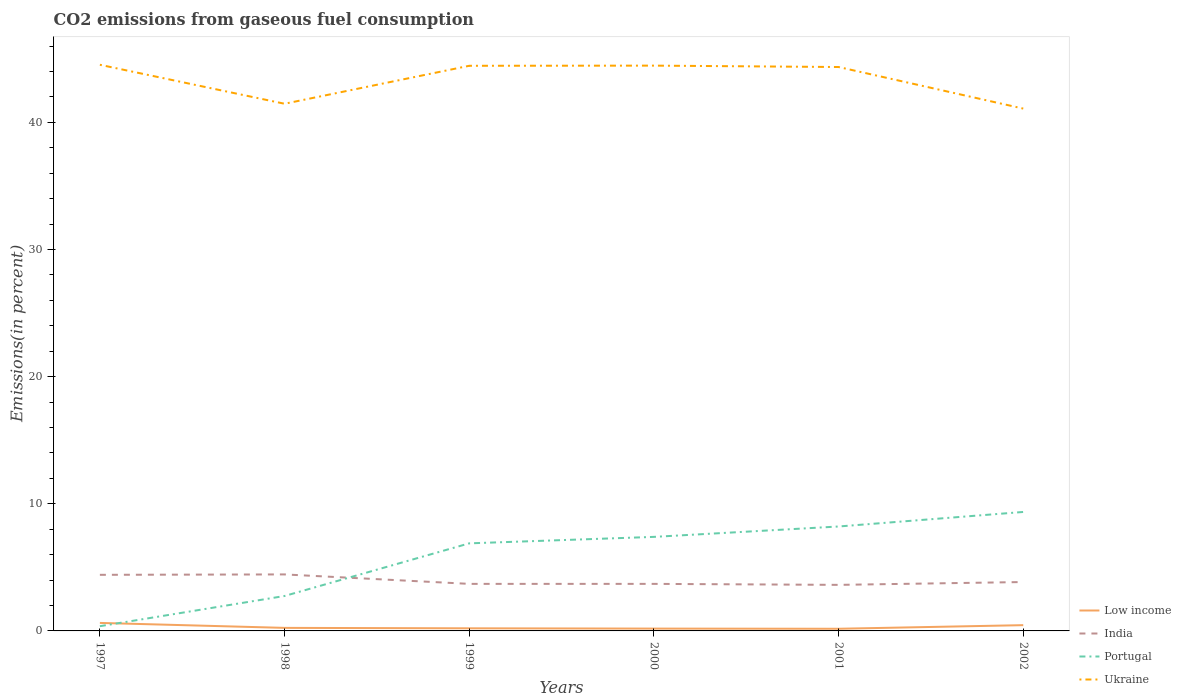Does the line corresponding to Portugal intersect with the line corresponding to Ukraine?
Provide a short and direct response. No. Across all years, what is the maximum total CO2 emitted in Ukraine?
Give a very brief answer. 41.08. In which year was the total CO2 emitted in Portugal maximum?
Provide a succinct answer. 1997. What is the total total CO2 emitted in Ukraine in the graph?
Ensure brevity in your answer.  0.38. What is the difference between the highest and the second highest total CO2 emitted in Ukraine?
Provide a succinct answer. 3.45. What is the difference between the highest and the lowest total CO2 emitted in Portugal?
Give a very brief answer. 4. Is the total CO2 emitted in India strictly greater than the total CO2 emitted in Portugal over the years?
Provide a succinct answer. No. Are the values on the major ticks of Y-axis written in scientific E-notation?
Your answer should be very brief. No. Does the graph contain any zero values?
Your answer should be very brief. No. What is the title of the graph?
Your answer should be very brief. CO2 emissions from gaseous fuel consumption. Does "Malta" appear as one of the legend labels in the graph?
Your response must be concise. No. What is the label or title of the Y-axis?
Ensure brevity in your answer.  Emissions(in percent). What is the Emissions(in percent) of Low income in 1997?
Provide a short and direct response. 0.63. What is the Emissions(in percent) in India in 1997?
Offer a terse response. 4.41. What is the Emissions(in percent) of Portugal in 1997?
Keep it short and to the point. 0.37. What is the Emissions(in percent) of Ukraine in 1997?
Offer a terse response. 44.53. What is the Emissions(in percent) of Low income in 1998?
Ensure brevity in your answer.  0.24. What is the Emissions(in percent) of India in 1998?
Provide a succinct answer. 4.44. What is the Emissions(in percent) in Portugal in 1998?
Give a very brief answer. 2.75. What is the Emissions(in percent) of Ukraine in 1998?
Offer a very short reply. 41.46. What is the Emissions(in percent) of Low income in 1999?
Keep it short and to the point. 0.21. What is the Emissions(in percent) of India in 1999?
Ensure brevity in your answer.  3.7. What is the Emissions(in percent) in Portugal in 1999?
Give a very brief answer. 6.89. What is the Emissions(in percent) of Ukraine in 1999?
Keep it short and to the point. 44.45. What is the Emissions(in percent) in Low income in 2000?
Your answer should be very brief. 0.18. What is the Emissions(in percent) in India in 2000?
Your answer should be very brief. 3.7. What is the Emissions(in percent) of Portugal in 2000?
Offer a terse response. 7.4. What is the Emissions(in percent) of Ukraine in 2000?
Give a very brief answer. 44.46. What is the Emissions(in percent) in Low income in 2001?
Your answer should be very brief. 0.17. What is the Emissions(in percent) in India in 2001?
Give a very brief answer. 3.62. What is the Emissions(in percent) of Portugal in 2001?
Your response must be concise. 8.21. What is the Emissions(in percent) in Ukraine in 2001?
Give a very brief answer. 44.35. What is the Emissions(in percent) in Low income in 2002?
Your answer should be compact. 0.45. What is the Emissions(in percent) in India in 2002?
Make the answer very short. 3.85. What is the Emissions(in percent) in Portugal in 2002?
Your response must be concise. 9.36. What is the Emissions(in percent) in Ukraine in 2002?
Offer a terse response. 41.08. Across all years, what is the maximum Emissions(in percent) of Low income?
Offer a very short reply. 0.63. Across all years, what is the maximum Emissions(in percent) in India?
Provide a succinct answer. 4.44. Across all years, what is the maximum Emissions(in percent) of Portugal?
Offer a terse response. 9.36. Across all years, what is the maximum Emissions(in percent) of Ukraine?
Offer a very short reply. 44.53. Across all years, what is the minimum Emissions(in percent) of Low income?
Give a very brief answer. 0.17. Across all years, what is the minimum Emissions(in percent) in India?
Make the answer very short. 3.62. Across all years, what is the minimum Emissions(in percent) in Portugal?
Your answer should be very brief. 0.37. Across all years, what is the minimum Emissions(in percent) of Ukraine?
Ensure brevity in your answer.  41.08. What is the total Emissions(in percent) of Low income in the graph?
Offer a terse response. 1.88. What is the total Emissions(in percent) of India in the graph?
Your answer should be very brief. 23.72. What is the total Emissions(in percent) of Portugal in the graph?
Offer a terse response. 34.97. What is the total Emissions(in percent) in Ukraine in the graph?
Your answer should be very brief. 260.33. What is the difference between the Emissions(in percent) of Low income in 1997 and that in 1998?
Your answer should be compact. 0.39. What is the difference between the Emissions(in percent) in India in 1997 and that in 1998?
Keep it short and to the point. -0.03. What is the difference between the Emissions(in percent) in Portugal in 1997 and that in 1998?
Make the answer very short. -2.38. What is the difference between the Emissions(in percent) in Ukraine in 1997 and that in 1998?
Your answer should be very brief. 3.07. What is the difference between the Emissions(in percent) in Low income in 1997 and that in 1999?
Provide a succinct answer. 0.42. What is the difference between the Emissions(in percent) in India in 1997 and that in 1999?
Provide a succinct answer. 0.71. What is the difference between the Emissions(in percent) of Portugal in 1997 and that in 1999?
Your answer should be compact. -6.52. What is the difference between the Emissions(in percent) of Ukraine in 1997 and that in 1999?
Offer a very short reply. 0.08. What is the difference between the Emissions(in percent) of Low income in 1997 and that in 2000?
Your answer should be compact. 0.45. What is the difference between the Emissions(in percent) of India in 1997 and that in 2000?
Offer a very short reply. 0.71. What is the difference between the Emissions(in percent) of Portugal in 1997 and that in 2000?
Ensure brevity in your answer.  -7.02. What is the difference between the Emissions(in percent) of Ukraine in 1997 and that in 2000?
Ensure brevity in your answer.  0.07. What is the difference between the Emissions(in percent) of Low income in 1997 and that in 2001?
Your answer should be very brief. 0.46. What is the difference between the Emissions(in percent) in India in 1997 and that in 2001?
Keep it short and to the point. 0.79. What is the difference between the Emissions(in percent) of Portugal in 1997 and that in 2001?
Your response must be concise. -7.84. What is the difference between the Emissions(in percent) of Ukraine in 1997 and that in 2001?
Your answer should be compact. 0.18. What is the difference between the Emissions(in percent) in Low income in 1997 and that in 2002?
Your answer should be very brief. 0.18. What is the difference between the Emissions(in percent) in India in 1997 and that in 2002?
Keep it short and to the point. 0.57. What is the difference between the Emissions(in percent) in Portugal in 1997 and that in 2002?
Your answer should be compact. -8.98. What is the difference between the Emissions(in percent) of Ukraine in 1997 and that in 2002?
Offer a very short reply. 3.45. What is the difference between the Emissions(in percent) of Low income in 1998 and that in 1999?
Ensure brevity in your answer.  0.03. What is the difference between the Emissions(in percent) of India in 1998 and that in 1999?
Provide a short and direct response. 0.74. What is the difference between the Emissions(in percent) of Portugal in 1998 and that in 1999?
Ensure brevity in your answer.  -4.14. What is the difference between the Emissions(in percent) of Ukraine in 1998 and that in 1999?
Offer a very short reply. -2.99. What is the difference between the Emissions(in percent) of Low income in 1998 and that in 2000?
Keep it short and to the point. 0.06. What is the difference between the Emissions(in percent) of India in 1998 and that in 2000?
Your answer should be compact. 0.74. What is the difference between the Emissions(in percent) of Portugal in 1998 and that in 2000?
Keep it short and to the point. -4.65. What is the difference between the Emissions(in percent) in Ukraine in 1998 and that in 2000?
Your response must be concise. -3. What is the difference between the Emissions(in percent) of Low income in 1998 and that in 2001?
Provide a succinct answer. 0.07. What is the difference between the Emissions(in percent) of India in 1998 and that in 2001?
Your response must be concise. 0.82. What is the difference between the Emissions(in percent) in Portugal in 1998 and that in 2001?
Your answer should be very brief. -5.47. What is the difference between the Emissions(in percent) of Ukraine in 1998 and that in 2001?
Make the answer very short. -2.89. What is the difference between the Emissions(in percent) of Low income in 1998 and that in 2002?
Provide a succinct answer. -0.21. What is the difference between the Emissions(in percent) of India in 1998 and that in 2002?
Give a very brief answer. 0.6. What is the difference between the Emissions(in percent) of Portugal in 1998 and that in 2002?
Give a very brief answer. -6.61. What is the difference between the Emissions(in percent) of Ukraine in 1998 and that in 2002?
Offer a terse response. 0.38. What is the difference between the Emissions(in percent) of Low income in 1999 and that in 2000?
Your response must be concise. 0.02. What is the difference between the Emissions(in percent) in Portugal in 1999 and that in 2000?
Make the answer very short. -0.51. What is the difference between the Emissions(in percent) of Ukraine in 1999 and that in 2000?
Your response must be concise. -0.01. What is the difference between the Emissions(in percent) of Low income in 1999 and that in 2001?
Ensure brevity in your answer.  0.04. What is the difference between the Emissions(in percent) of India in 1999 and that in 2001?
Keep it short and to the point. 0.08. What is the difference between the Emissions(in percent) in Portugal in 1999 and that in 2001?
Keep it short and to the point. -1.33. What is the difference between the Emissions(in percent) in Ukraine in 1999 and that in 2001?
Provide a short and direct response. 0.1. What is the difference between the Emissions(in percent) in Low income in 1999 and that in 2002?
Keep it short and to the point. -0.25. What is the difference between the Emissions(in percent) in India in 1999 and that in 2002?
Keep it short and to the point. -0.14. What is the difference between the Emissions(in percent) of Portugal in 1999 and that in 2002?
Give a very brief answer. -2.47. What is the difference between the Emissions(in percent) in Ukraine in 1999 and that in 2002?
Make the answer very short. 3.37. What is the difference between the Emissions(in percent) of Low income in 2000 and that in 2001?
Ensure brevity in your answer.  0.01. What is the difference between the Emissions(in percent) of India in 2000 and that in 2001?
Your response must be concise. 0.08. What is the difference between the Emissions(in percent) of Portugal in 2000 and that in 2001?
Offer a terse response. -0.82. What is the difference between the Emissions(in percent) in Ukraine in 2000 and that in 2001?
Offer a terse response. 0.11. What is the difference between the Emissions(in percent) of Low income in 2000 and that in 2002?
Provide a short and direct response. -0.27. What is the difference between the Emissions(in percent) of India in 2000 and that in 2002?
Your answer should be compact. -0.14. What is the difference between the Emissions(in percent) in Portugal in 2000 and that in 2002?
Offer a very short reply. -1.96. What is the difference between the Emissions(in percent) in Ukraine in 2000 and that in 2002?
Offer a very short reply. 3.38. What is the difference between the Emissions(in percent) in Low income in 2001 and that in 2002?
Provide a succinct answer. -0.28. What is the difference between the Emissions(in percent) of India in 2001 and that in 2002?
Your response must be concise. -0.22. What is the difference between the Emissions(in percent) in Portugal in 2001 and that in 2002?
Give a very brief answer. -1.14. What is the difference between the Emissions(in percent) in Ukraine in 2001 and that in 2002?
Make the answer very short. 3.27. What is the difference between the Emissions(in percent) in Low income in 1997 and the Emissions(in percent) in India in 1998?
Provide a succinct answer. -3.81. What is the difference between the Emissions(in percent) of Low income in 1997 and the Emissions(in percent) of Portugal in 1998?
Your response must be concise. -2.12. What is the difference between the Emissions(in percent) in Low income in 1997 and the Emissions(in percent) in Ukraine in 1998?
Make the answer very short. -40.83. What is the difference between the Emissions(in percent) in India in 1997 and the Emissions(in percent) in Portugal in 1998?
Provide a short and direct response. 1.66. What is the difference between the Emissions(in percent) in India in 1997 and the Emissions(in percent) in Ukraine in 1998?
Your response must be concise. -37.05. What is the difference between the Emissions(in percent) in Portugal in 1997 and the Emissions(in percent) in Ukraine in 1998?
Offer a terse response. -41.09. What is the difference between the Emissions(in percent) in Low income in 1997 and the Emissions(in percent) in India in 1999?
Keep it short and to the point. -3.07. What is the difference between the Emissions(in percent) in Low income in 1997 and the Emissions(in percent) in Portugal in 1999?
Your response must be concise. -6.26. What is the difference between the Emissions(in percent) in Low income in 1997 and the Emissions(in percent) in Ukraine in 1999?
Give a very brief answer. -43.82. What is the difference between the Emissions(in percent) of India in 1997 and the Emissions(in percent) of Portugal in 1999?
Your answer should be very brief. -2.48. What is the difference between the Emissions(in percent) of India in 1997 and the Emissions(in percent) of Ukraine in 1999?
Provide a short and direct response. -40.04. What is the difference between the Emissions(in percent) of Portugal in 1997 and the Emissions(in percent) of Ukraine in 1999?
Ensure brevity in your answer.  -44.08. What is the difference between the Emissions(in percent) of Low income in 1997 and the Emissions(in percent) of India in 2000?
Offer a terse response. -3.07. What is the difference between the Emissions(in percent) of Low income in 1997 and the Emissions(in percent) of Portugal in 2000?
Provide a short and direct response. -6.77. What is the difference between the Emissions(in percent) in Low income in 1997 and the Emissions(in percent) in Ukraine in 2000?
Your answer should be compact. -43.83. What is the difference between the Emissions(in percent) in India in 1997 and the Emissions(in percent) in Portugal in 2000?
Give a very brief answer. -2.98. What is the difference between the Emissions(in percent) in India in 1997 and the Emissions(in percent) in Ukraine in 2000?
Give a very brief answer. -40.05. What is the difference between the Emissions(in percent) in Portugal in 1997 and the Emissions(in percent) in Ukraine in 2000?
Your answer should be very brief. -44.09. What is the difference between the Emissions(in percent) of Low income in 1997 and the Emissions(in percent) of India in 2001?
Provide a succinct answer. -2.99. What is the difference between the Emissions(in percent) in Low income in 1997 and the Emissions(in percent) in Portugal in 2001?
Keep it short and to the point. -7.58. What is the difference between the Emissions(in percent) in Low income in 1997 and the Emissions(in percent) in Ukraine in 2001?
Ensure brevity in your answer.  -43.72. What is the difference between the Emissions(in percent) of India in 1997 and the Emissions(in percent) of Portugal in 2001?
Give a very brief answer. -3.8. What is the difference between the Emissions(in percent) of India in 1997 and the Emissions(in percent) of Ukraine in 2001?
Offer a very short reply. -39.94. What is the difference between the Emissions(in percent) in Portugal in 1997 and the Emissions(in percent) in Ukraine in 2001?
Your answer should be very brief. -43.98. What is the difference between the Emissions(in percent) in Low income in 1997 and the Emissions(in percent) in India in 2002?
Your answer should be very brief. -3.22. What is the difference between the Emissions(in percent) in Low income in 1997 and the Emissions(in percent) in Portugal in 2002?
Make the answer very short. -8.73. What is the difference between the Emissions(in percent) of Low income in 1997 and the Emissions(in percent) of Ukraine in 2002?
Offer a terse response. -40.45. What is the difference between the Emissions(in percent) in India in 1997 and the Emissions(in percent) in Portugal in 2002?
Your answer should be compact. -4.94. What is the difference between the Emissions(in percent) in India in 1997 and the Emissions(in percent) in Ukraine in 2002?
Keep it short and to the point. -36.67. What is the difference between the Emissions(in percent) in Portugal in 1997 and the Emissions(in percent) in Ukraine in 2002?
Your response must be concise. -40.71. What is the difference between the Emissions(in percent) in Low income in 1998 and the Emissions(in percent) in India in 1999?
Your answer should be compact. -3.46. What is the difference between the Emissions(in percent) in Low income in 1998 and the Emissions(in percent) in Portugal in 1999?
Ensure brevity in your answer.  -6.65. What is the difference between the Emissions(in percent) of Low income in 1998 and the Emissions(in percent) of Ukraine in 1999?
Offer a terse response. -44.21. What is the difference between the Emissions(in percent) in India in 1998 and the Emissions(in percent) in Portugal in 1999?
Your response must be concise. -2.44. What is the difference between the Emissions(in percent) of India in 1998 and the Emissions(in percent) of Ukraine in 1999?
Offer a very short reply. -40. What is the difference between the Emissions(in percent) of Portugal in 1998 and the Emissions(in percent) of Ukraine in 1999?
Ensure brevity in your answer.  -41.7. What is the difference between the Emissions(in percent) in Low income in 1998 and the Emissions(in percent) in India in 2000?
Keep it short and to the point. -3.46. What is the difference between the Emissions(in percent) of Low income in 1998 and the Emissions(in percent) of Portugal in 2000?
Keep it short and to the point. -7.16. What is the difference between the Emissions(in percent) in Low income in 1998 and the Emissions(in percent) in Ukraine in 2000?
Provide a succinct answer. -44.22. What is the difference between the Emissions(in percent) in India in 1998 and the Emissions(in percent) in Portugal in 2000?
Your answer should be compact. -2.95. What is the difference between the Emissions(in percent) of India in 1998 and the Emissions(in percent) of Ukraine in 2000?
Your answer should be very brief. -40.02. What is the difference between the Emissions(in percent) of Portugal in 1998 and the Emissions(in percent) of Ukraine in 2000?
Your response must be concise. -41.71. What is the difference between the Emissions(in percent) in Low income in 1998 and the Emissions(in percent) in India in 2001?
Ensure brevity in your answer.  -3.38. What is the difference between the Emissions(in percent) of Low income in 1998 and the Emissions(in percent) of Portugal in 2001?
Your answer should be compact. -7.97. What is the difference between the Emissions(in percent) of Low income in 1998 and the Emissions(in percent) of Ukraine in 2001?
Ensure brevity in your answer.  -44.11. What is the difference between the Emissions(in percent) of India in 1998 and the Emissions(in percent) of Portugal in 2001?
Your answer should be compact. -3.77. What is the difference between the Emissions(in percent) of India in 1998 and the Emissions(in percent) of Ukraine in 2001?
Offer a very short reply. -39.91. What is the difference between the Emissions(in percent) in Portugal in 1998 and the Emissions(in percent) in Ukraine in 2001?
Your answer should be very brief. -41.6. What is the difference between the Emissions(in percent) in Low income in 1998 and the Emissions(in percent) in India in 2002?
Your answer should be very brief. -3.61. What is the difference between the Emissions(in percent) of Low income in 1998 and the Emissions(in percent) of Portugal in 2002?
Offer a very short reply. -9.12. What is the difference between the Emissions(in percent) in Low income in 1998 and the Emissions(in percent) in Ukraine in 2002?
Your response must be concise. -40.84. What is the difference between the Emissions(in percent) of India in 1998 and the Emissions(in percent) of Portugal in 2002?
Offer a terse response. -4.91. What is the difference between the Emissions(in percent) in India in 1998 and the Emissions(in percent) in Ukraine in 2002?
Ensure brevity in your answer.  -36.64. What is the difference between the Emissions(in percent) of Portugal in 1998 and the Emissions(in percent) of Ukraine in 2002?
Your answer should be very brief. -38.33. What is the difference between the Emissions(in percent) in Low income in 1999 and the Emissions(in percent) in India in 2000?
Provide a succinct answer. -3.5. What is the difference between the Emissions(in percent) in Low income in 1999 and the Emissions(in percent) in Portugal in 2000?
Ensure brevity in your answer.  -7.19. What is the difference between the Emissions(in percent) in Low income in 1999 and the Emissions(in percent) in Ukraine in 2000?
Make the answer very short. -44.26. What is the difference between the Emissions(in percent) of India in 1999 and the Emissions(in percent) of Portugal in 2000?
Provide a succinct answer. -3.7. What is the difference between the Emissions(in percent) of India in 1999 and the Emissions(in percent) of Ukraine in 2000?
Offer a very short reply. -40.76. What is the difference between the Emissions(in percent) of Portugal in 1999 and the Emissions(in percent) of Ukraine in 2000?
Make the answer very short. -37.57. What is the difference between the Emissions(in percent) of Low income in 1999 and the Emissions(in percent) of India in 2001?
Ensure brevity in your answer.  -3.42. What is the difference between the Emissions(in percent) in Low income in 1999 and the Emissions(in percent) in Portugal in 2001?
Provide a short and direct response. -8.01. What is the difference between the Emissions(in percent) of Low income in 1999 and the Emissions(in percent) of Ukraine in 2001?
Provide a succinct answer. -44.15. What is the difference between the Emissions(in percent) in India in 1999 and the Emissions(in percent) in Portugal in 2001?
Provide a short and direct response. -4.51. What is the difference between the Emissions(in percent) of India in 1999 and the Emissions(in percent) of Ukraine in 2001?
Offer a very short reply. -40.65. What is the difference between the Emissions(in percent) of Portugal in 1999 and the Emissions(in percent) of Ukraine in 2001?
Offer a terse response. -37.46. What is the difference between the Emissions(in percent) in Low income in 1999 and the Emissions(in percent) in India in 2002?
Ensure brevity in your answer.  -3.64. What is the difference between the Emissions(in percent) of Low income in 1999 and the Emissions(in percent) of Portugal in 2002?
Offer a terse response. -9.15. What is the difference between the Emissions(in percent) in Low income in 1999 and the Emissions(in percent) in Ukraine in 2002?
Your answer should be compact. -40.88. What is the difference between the Emissions(in percent) of India in 1999 and the Emissions(in percent) of Portugal in 2002?
Provide a succinct answer. -5.66. What is the difference between the Emissions(in percent) in India in 1999 and the Emissions(in percent) in Ukraine in 2002?
Provide a short and direct response. -37.38. What is the difference between the Emissions(in percent) in Portugal in 1999 and the Emissions(in percent) in Ukraine in 2002?
Provide a succinct answer. -34.19. What is the difference between the Emissions(in percent) in Low income in 2000 and the Emissions(in percent) in India in 2001?
Your response must be concise. -3.44. What is the difference between the Emissions(in percent) of Low income in 2000 and the Emissions(in percent) of Portugal in 2001?
Ensure brevity in your answer.  -8.03. What is the difference between the Emissions(in percent) in Low income in 2000 and the Emissions(in percent) in Ukraine in 2001?
Your response must be concise. -44.17. What is the difference between the Emissions(in percent) of India in 2000 and the Emissions(in percent) of Portugal in 2001?
Give a very brief answer. -4.51. What is the difference between the Emissions(in percent) in India in 2000 and the Emissions(in percent) in Ukraine in 2001?
Your answer should be very brief. -40.65. What is the difference between the Emissions(in percent) of Portugal in 2000 and the Emissions(in percent) of Ukraine in 2001?
Give a very brief answer. -36.95. What is the difference between the Emissions(in percent) of Low income in 2000 and the Emissions(in percent) of India in 2002?
Give a very brief answer. -3.66. What is the difference between the Emissions(in percent) of Low income in 2000 and the Emissions(in percent) of Portugal in 2002?
Make the answer very short. -9.17. What is the difference between the Emissions(in percent) in Low income in 2000 and the Emissions(in percent) in Ukraine in 2002?
Ensure brevity in your answer.  -40.9. What is the difference between the Emissions(in percent) of India in 2000 and the Emissions(in percent) of Portugal in 2002?
Your answer should be compact. -5.66. What is the difference between the Emissions(in percent) in India in 2000 and the Emissions(in percent) in Ukraine in 2002?
Your response must be concise. -37.38. What is the difference between the Emissions(in percent) in Portugal in 2000 and the Emissions(in percent) in Ukraine in 2002?
Give a very brief answer. -33.68. What is the difference between the Emissions(in percent) of Low income in 2001 and the Emissions(in percent) of India in 2002?
Make the answer very short. -3.68. What is the difference between the Emissions(in percent) of Low income in 2001 and the Emissions(in percent) of Portugal in 2002?
Give a very brief answer. -9.19. What is the difference between the Emissions(in percent) of Low income in 2001 and the Emissions(in percent) of Ukraine in 2002?
Offer a terse response. -40.91. What is the difference between the Emissions(in percent) in India in 2001 and the Emissions(in percent) in Portugal in 2002?
Your answer should be very brief. -5.73. What is the difference between the Emissions(in percent) in India in 2001 and the Emissions(in percent) in Ukraine in 2002?
Provide a short and direct response. -37.46. What is the difference between the Emissions(in percent) in Portugal in 2001 and the Emissions(in percent) in Ukraine in 2002?
Offer a very short reply. -32.87. What is the average Emissions(in percent) of Low income per year?
Your answer should be very brief. 0.31. What is the average Emissions(in percent) of India per year?
Your answer should be very brief. 3.95. What is the average Emissions(in percent) of Portugal per year?
Keep it short and to the point. 5.83. What is the average Emissions(in percent) in Ukraine per year?
Your answer should be compact. 43.39. In the year 1997, what is the difference between the Emissions(in percent) of Low income and Emissions(in percent) of India?
Your answer should be compact. -3.78. In the year 1997, what is the difference between the Emissions(in percent) of Low income and Emissions(in percent) of Portugal?
Keep it short and to the point. 0.26. In the year 1997, what is the difference between the Emissions(in percent) of Low income and Emissions(in percent) of Ukraine?
Ensure brevity in your answer.  -43.9. In the year 1997, what is the difference between the Emissions(in percent) of India and Emissions(in percent) of Portugal?
Provide a succinct answer. 4.04. In the year 1997, what is the difference between the Emissions(in percent) in India and Emissions(in percent) in Ukraine?
Your answer should be compact. -40.11. In the year 1997, what is the difference between the Emissions(in percent) in Portugal and Emissions(in percent) in Ukraine?
Provide a short and direct response. -44.15. In the year 1998, what is the difference between the Emissions(in percent) in Low income and Emissions(in percent) in India?
Your response must be concise. -4.2. In the year 1998, what is the difference between the Emissions(in percent) in Low income and Emissions(in percent) in Portugal?
Ensure brevity in your answer.  -2.51. In the year 1998, what is the difference between the Emissions(in percent) in Low income and Emissions(in percent) in Ukraine?
Keep it short and to the point. -41.22. In the year 1998, what is the difference between the Emissions(in percent) in India and Emissions(in percent) in Portugal?
Keep it short and to the point. 1.7. In the year 1998, what is the difference between the Emissions(in percent) of India and Emissions(in percent) of Ukraine?
Keep it short and to the point. -37.02. In the year 1998, what is the difference between the Emissions(in percent) in Portugal and Emissions(in percent) in Ukraine?
Offer a terse response. -38.71. In the year 1999, what is the difference between the Emissions(in percent) in Low income and Emissions(in percent) in India?
Offer a very short reply. -3.5. In the year 1999, what is the difference between the Emissions(in percent) of Low income and Emissions(in percent) of Portugal?
Your answer should be very brief. -6.68. In the year 1999, what is the difference between the Emissions(in percent) of Low income and Emissions(in percent) of Ukraine?
Keep it short and to the point. -44.24. In the year 1999, what is the difference between the Emissions(in percent) in India and Emissions(in percent) in Portugal?
Give a very brief answer. -3.19. In the year 1999, what is the difference between the Emissions(in percent) in India and Emissions(in percent) in Ukraine?
Offer a very short reply. -40.75. In the year 1999, what is the difference between the Emissions(in percent) of Portugal and Emissions(in percent) of Ukraine?
Provide a short and direct response. -37.56. In the year 2000, what is the difference between the Emissions(in percent) in Low income and Emissions(in percent) in India?
Make the answer very short. -3.52. In the year 2000, what is the difference between the Emissions(in percent) in Low income and Emissions(in percent) in Portugal?
Your response must be concise. -7.21. In the year 2000, what is the difference between the Emissions(in percent) in Low income and Emissions(in percent) in Ukraine?
Provide a succinct answer. -44.28. In the year 2000, what is the difference between the Emissions(in percent) of India and Emissions(in percent) of Portugal?
Provide a succinct answer. -3.7. In the year 2000, what is the difference between the Emissions(in percent) in India and Emissions(in percent) in Ukraine?
Your response must be concise. -40.76. In the year 2000, what is the difference between the Emissions(in percent) of Portugal and Emissions(in percent) of Ukraine?
Ensure brevity in your answer.  -37.06. In the year 2001, what is the difference between the Emissions(in percent) of Low income and Emissions(in percent) of India?
Your response must be concise. -3.45. In the year 2001, what is the difference between the Emissions(in percent) in Low income and Emissions(in percent) in Portugal?
Offer a very short reply. -8.04. In the year 2001, what is the difference between the Emissions(in percent) of Low income and Emissions(in percent) of Ukraine?
Your response must be concise. -44.18. In the year 2001, what is the difference between the Emissions(in percent) in India and Emissions(in percent) in Portugal?
Make the answer very short. -4.59. In the year 2001, what is the difference between the Emissions(in percent) of India and Emissions(in percent) of Ukraine?
Give a very brief answer. -40.73. In the year 2001, what is the difference between the Emissions(in percent) in Portugal and Emissions(in percent) in Ukraine?
Your response must be concise. -36.14. In the year 2002, what is the difference between the Emissions(in percent) in Low income and Emissions(in percent) in India?
Your answer should be very brief. -3.39. In the year 2002, what is the difference between the Emissions(in percent) in Low income and Emissions(in percent) in Portugal?
Give a very brief answer. -8.9. In the year 2002, what is the difference between the Emissions(in percent) in Low income and Emissions(in percent) in Ukraine?
Your response must be concise. -40.63. In the year 2002, what is the difference between the Emissions(in percent) in India and Emissions(in percent) in Portugal?
Keep it short and to the point. -5.51. In the year 2002, what is the difference between the Emissions(in percent) in India and Emissions(in percent) in Ukraine?
Your response must be concise. -37.24. In the year 2002, what is the difference between the Emissions(in percent) of Portugal and Emissions(in percent) of Ukraine?
Offer a terse response. -31.72. What is the ratio of the Emissions(in percent) in Low income in 1997 to that in 1998?
Give a very brief answer. 2.63. What is the ratio of the Emissions(in percent) of Portugal in 1997 to that in 1998?
Keep it short and to the point. 0.14. What is the ratio of the Emissions(in percent) of Ukraine in 1997 to that in 1998?
Your response must be concise. 1.07. What is the ratio of the Emissions(in percent) in Low income in 1997 to that in 1999?
Provide a succinct answer. 3.07. What is the ratio of the Emissions(in percent) of India in 1997 to that in 1999?
Keep it short and to the point. 1.19. What is the ratio of the Emissions(in percent) in Portugal in 1997 to that in 1999?
Offer a terse response. 0.05. What is the ratio of the Emissions(in percent) of Ukraine in 1997 to that in 1999?
Your answer should be very brief. 1. What is the ratio of the Emissions(in percent) in Low income in 1997 to that in 2000?
Provide a succinct answer. 3.44. What is the ratio of the Emissions(in percent) in India in 1997 to that in 2000?
Your response must be concise. 1.19. What is the ratio of the Emissions(in percent) of Portugal in 1997 to that in 2000?
Your response must be concise. 0.05. What is the ratio of the Emissions(in percent) in Ukraine in 1997 to that in 2000?
Your answer should be compact. 1. What is the ratio of the Emissions(in percent) of Low income in 1997 to that in 2001?
Give a very brief answer. 3.72. What is the ratio of the Emissions(in percent) in India in 1997 to that in 2001?
Provide a short and direct response. 1.22. What is the ratio of the Emissions(in percent) in Portugal in 1997 to that in 2001?
Keep it short and to the point. 0.05. What is the ratio of the Emissions(in percent) of Ukraine in 1997 to that in 2001?
Your answer should be very brief. 1. What is the ratio of the Emissions(in percent) in Low income in 1997 to that in 2002?
Your answer should be compact. 1.39. What is the ratio of the Emissions(in percent) in India in 1997 to that in 2002?
Provide a short and direct response. 1.15. What is the ratio of the Emissions(in percent) of Portugal in 1997 to that in 2002?
Make the answer very short. 0.04. What is the ratio of the Emissions(in percent) in Ukraine in 1997 to that in 2002?
Ensure brevity in your answer.  1.08. What is the ratio of the Emissions(in percent) of Low income in 1998 to that in 1999?
Offer a terse response. 1.17. What is the ratio of the Emissions(in percent) in India in 1998 to that in 1999?
Provide a succinct answer. 1.2. What is the ratio of the Emissions(in percent) of Portugal in 1998 to that in 1999?
Give a very brief answer. 0.4. What is the ratio of the Emissions(in percent) in Ukraine in 1998 to that in 1999?
Give a very brief answer. 0.93. What is the ratio of the Emissions(in percent) of Low income in 1998 to that in 2000?
Your response must be concise. 1.31. What is the ratio of the Emissions(in percent) of India in 1998 to that in 2000?
Provide a short and direct response. 1.2. What is the ratio of the Emissions(in percent) in Portugal in 1998 to that in 2000?
Your response must be concise. 0.37. What is the ratio of the Emissions(in percent) of Ukraine in 1998 to that in 2000?
Provide a succinct answer. 0.93. What is the ratio of the Emissions(in percent) in Low income in 1998 to that in 2001?
Offer a terse response. 1.42. What is the ratio of the Emissions(in percent) of India in 1998 to that in 2001?
Ensure brevity in your answer.  1.23. What is the ratio of the Emissions(in percent) in Portugal in 1998 to that in 2001?
Keep it short and to the point. 0.33. What is the ratio of the Emissions(in percent) in Ukraine in 1998 to that in 2001?
Provide a succinct answer. 0.93. What is the ratio of the Emissions(in percent) in Low income in 1998 to that in 2002?
Your response must be concise. 0.53. What is the ratio of the Emissions(in percent) in India in 1998 to that in 2002?
Your response must be concise. 1.16. What is the ratio of the Emissions(in percent) of Portugal in 1998 to that in 2002?
Ensure brevity in your answer.  0.29. What is the ratio of the Emissions(in percent) in Ukraine in 1998 to that in 2002?
Keep it short and to the point. 1.01. What is the ratio of the Emissions(in percent) in Low income in 1999 to that in 2000?
Ensure brevity in your answer.  1.12. What is the ratio of the Emissions(in percent) of Portugal in 1999 to that in 2000?
Offer a terse response. 0.93. What is the ratio of the Emissions(in percent) in Ukraine in 1999 to that in 2000?
Offer a terse response. 1. What is the ratio of the Emissions(in percent) of Low income in 1999 to that in 2001?
Offer a terse response. 1.21. What is the ratio of the Emissions(in percent) of India in 1999 to that in 2001?
Your answer should be very brief. 1.02. What is the ratio of the Emissions(in percent) in Portugal in 1999 to that in 2001?
Your answer should be very brief. 0.84. What is the ratio of the Emissions(in percent) in Ukraine in 1999 to that in 2001?
Provide a succinct answer. 1. What is the ratio of the Emissions(in percent) in Low income in 1999 to that in 2002?
Offer a very short reply. 0.45. What is the ratio of the Emissions(in percent) in India in 1999 to that in 2002?
Your answer should be compact. 0.96. What is the ratio of the Emissions(in percent) in Portugal in 1999 to that in 2002?
Make the answer very short. 0.74. What is the ratio of the Emissions(in percent) in Ukraine in 1999 to that in 2002?
Provide a succinct answer. 1.08. What is the ratio of the Emissions(in percent) of Low income in 2000 to that in 2001?
Make the answer very short. 1.08. What is the ratio of the Emissions(in percent) of India in 2000 to that in 2001?
Your answer should be compact. 1.02. What is the ratio of the Emissions(in percent) of Portugal in 2000 to that in 2001?
Your answer should be very brief. 0.9. What is the ratio of the Emissions(in percent) in Ukraine in 2000 to that in 2001?
Provide a succinct answer. 1. What is the ratio of the Emissions(in percent) of Low income in 2000 to that in 2002?
Offer a terse response. 0.4. What is the ratio of the Emissions(in percent) in India in 2000 to that in 2002?
Your answer should be compact. 0.96. What is the ratio of the Emissions(in percent) of Portugal in 2000 to that in 2002?
Offer a terse response. 0.79. What is the ratio of the Emissions(in percent) of Ukraine in 2000 to that in 2002?
Your answer should be compact. 1.08. What is the ratio of the Emissions(in percent) of Low income in 2001 to that in 2002?
Give a very brief answer. 0.37. What is the ratio of the Emissions(in percent) of India in 2001 to that in 2002?
Provide a succinct answer. 0.94. What is the ratio of the Emissions(in percent) in Portugal in 2001 to that in 2002?
Provide a succinct answer. 0.88. What is the ratio of the Emissions(in percent) in Ukraine in 2001 to that in 2002?
Give a very brief answer. 1.08. What is the difference between the highest and the second highest Emissions(in percent) in Low income?
Keep it short and to the point. 0.18. What is the difference between the highest and the second highest Emissions(in percent) in India?
Your answer should be compact. 0.03. What is the difference between the highest and the second highest Emissions(in percent) of Portugal?
Provide a succinct answer. 1.14. What is the difference between the highest and the second highest Emissions(in percent) of Ukraine?
Give a very brief answer. 0.07. What is the difference between the highest and the lowest Emissions(in percent) in Low income?
Ensure brevity in your answer.  0.46. What is the difference between the highest and the lowest Emissions(in percent) of India?
Ensure brevity in your answer.  0.82. What is the difference between the highest and the lowest Emissions(in percent) of Portugal?
Provide a short and direct response. 8.98. What is the difference between the highest and the lowest Emissions(in percent) in Ukraine?
Ensure brevity in your answer.  3.45. 